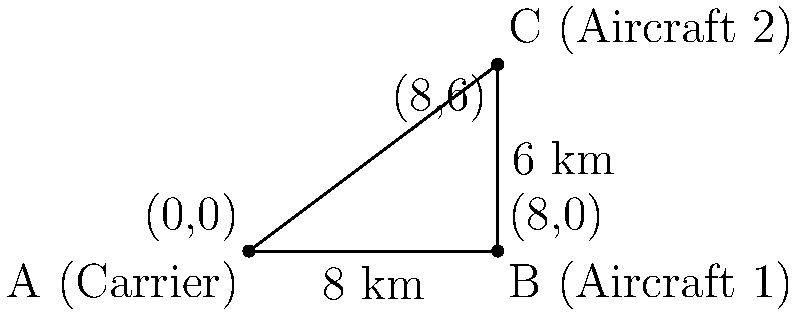During a simultaneous launch and recovery operation, Aircraft 1 is 8 km east of the carrier, while Aircraft 2 is 8 km east and 6 km north of the carrier. What is the minimum safe separation distance between the two aircraft, rounded to the nearest tenth of a kilometer? To solve this problem, we can use the Pythagorean theorem:

1) First, let's identify the triangle formed by the carrier and the two aircraft:
   - The carrier is at point A
   - Aircraft 1 is at point B
   - Aircraft 2 is at point C

2) We know the distances:
   - AB = 8 km (Aircraft 1's distance from the carrier)
   - BC = 6 km (The north-south distance between Aircraft 1 and Aircraft 2)

3) The distance AC (between the carrier and Aircraft 2) isn't needed for this calculation.

4) We want to find the length of side AC, which represents the distance between the two aircraft.

5) Using the Pythagorean theorem: $AC^2 = AB^2 + BC^2$

6) Substituting the known values:
   $AC^2 = 8^2 + 6^2$

7) Simplifying:
   $AC^2 = 64 + 36 = 100$

8) Taking the square root of both sides:
   $AC = \sqrt{100} = 10$

9) Rounding to the nearest tenth:
   $AC \approx 10.0$ km

Therefore, the minimum safe separation distance between the two aircraft is 10.0 km.
Answer: 10.0 km 